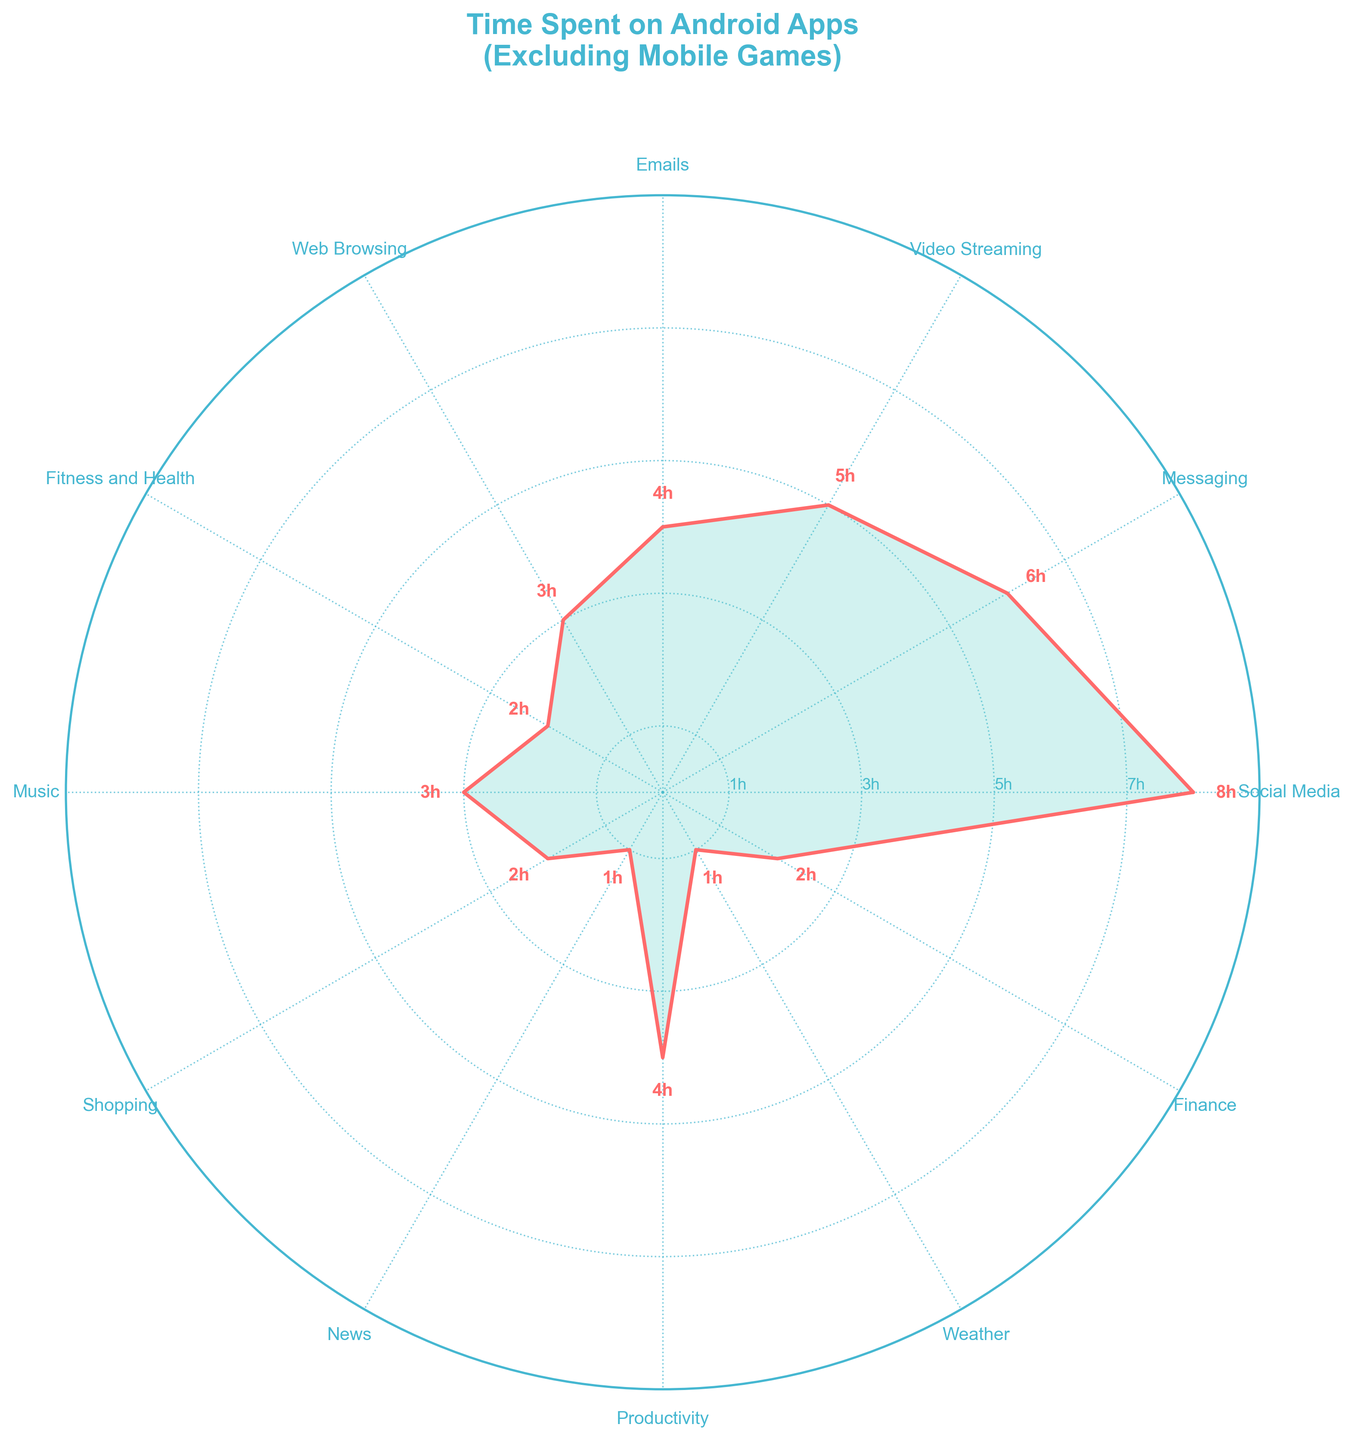Which app category has the highest time spent? By examining the lengths of the spokes in the rose chart, the category with the highest time spent is "Social Media" with 8 hours.
Answer: Social Media What's the range of time spent on apps? The maximum time spent is 8 hours (Social Media) and the minimum is 1 hour (News and Weather). The range is calculated as 8 - 1 = 7 hours.
Answer: 7 hours How much more time do users spend on Messaging apps compared to Weather apps? Messaging apps have a time of 6 hours, while Weather apps have 1 hour. The difference is calculated as 6 - 1 = 5 hours.
Answer: 5 hours Which app categories have the same amount of time spent? By looking at the rose chart, Music and Web Browsing both have 3 hours. Similarly, Fitness and Health, Shopping, and Finance each have 2 hours.
Answer: Music & Web Browsing; Fitness and Health, Shopping, & Finance What's the average time spent on Productivity and Video Streaming apps? Productivity has 4 hours, and Video Streaming has 5 hours. The average is calculated as (4 + 5) / 2 = 4.5 hours.
Answer: 4.5 hours Are there any app categories with less than 2 hours of time spent? By inspecting the rose chart, no app categories have less than 2 hours of time spent.
Answer: No What is the total time spent on all app categories combined? The total time spent is the sum of all individual times: 8 + 6 + 5 + 4 + 3 + 2 + 3 + 2 + 1 + 4 + 1 + 2 = 41 hours.
Answer: 41 hours Which categories do users spend the same amount of time on, and how much is it? Fitness and Health, Shopping, and Finance each have 2 hours, while Music and Web Browsing each have 3 hours.
Answer: 2 hours and 3 hours 